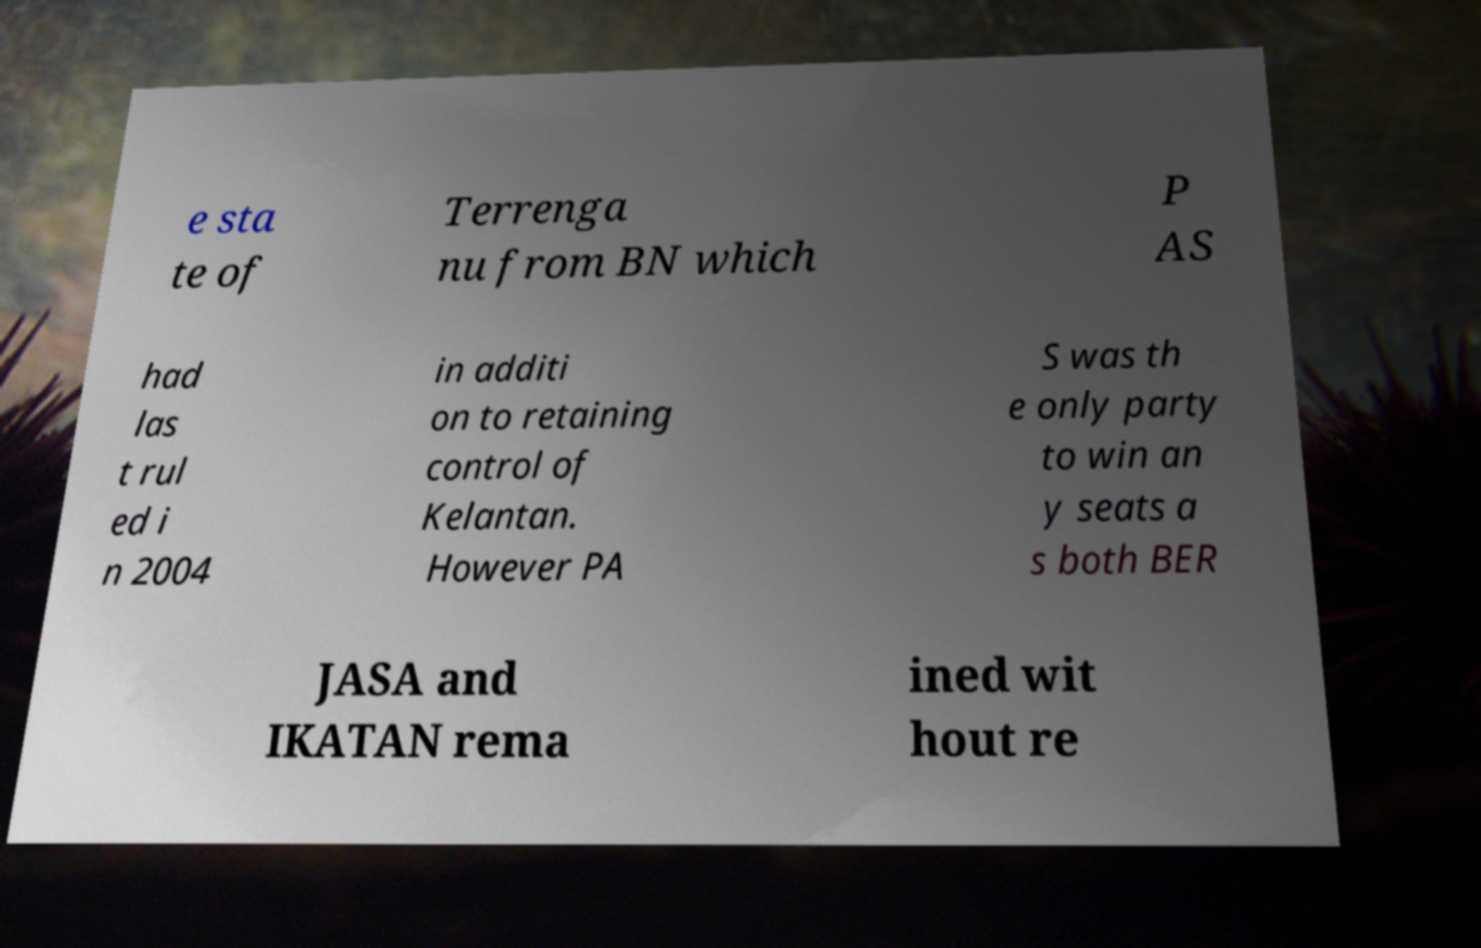Could you extract and type out the text from this image? e sta te of Terrenga nu from BN which P AS had las t rul ed i n 2004 in additi on to retaining control of Kelantan. However PA S was th e only party to win an y seats a s both BER JASA and IKATAN rema ined wit hout re 